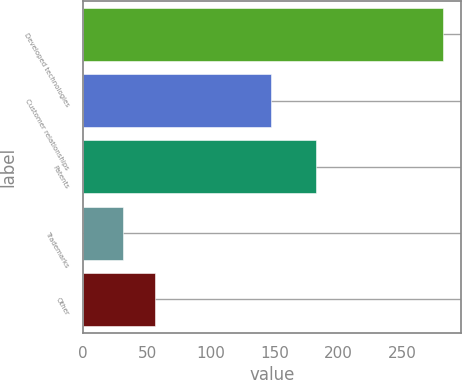Convert chart. <chart><loc_0><loc_0><loc_500><loc_500><bar_chart><fcel>Developed technologies<fcel>Customer relationships<fcel>Patents<fcel>Trademarks<fcel>Other<nl><fcel>282<fcel>147<fcel>182<fcel>31<fcel>56.1<nl></chart> 